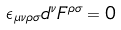Convert formula to latex. <formula><loc_0><loc_0><loc_500><loc_500>\epsilon _ { \mu \nu \rho \sigma } d ^ { \nu } F ^ { \rho \sigma } = 0</formula> 